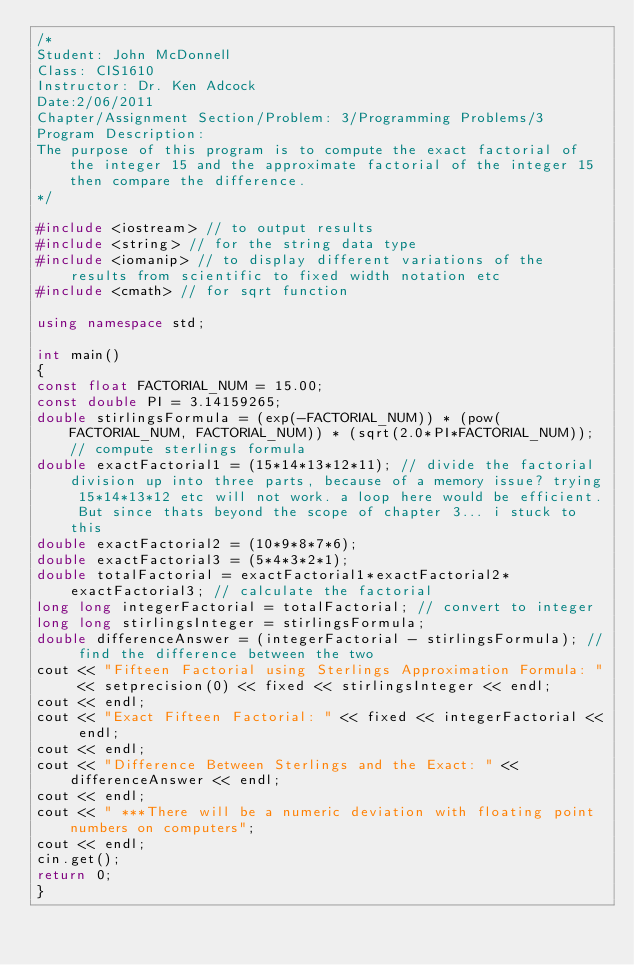<code> <loc_0><loc_0><loc_500><loc_500><_C++_>/* 
Student: John McDonnell
Class: CIS1610
Instructor: Dr. Ken Adcock
Date:2/06/2011
Chapter/Assignment Section/Problem: 3/Programming Problems/3
Program Description:
The purpose of this program is to compute the exact factorial of the integer 15 and the approximate factorial of the integer 15 then compare the difference.
*/

#include <iostream> // to output results
#include <string> // for the string data type
#include <iomanip> // to display different variations of the results from scientific to fixed width notation etc
#include <cmath> // for sqrt function

using namespace std;

int main() 
{
const float FACTORIAL_NUM = 15.00;
const double PI = 3.14159265;
double stirlingsFormula = (exp(-FACTORIAL_NUM)) * (pow(FACTORIAL_NUM, FACTORIAL_NUM)) * (sqrt(2.0*PI*FACTORIAL_NUM)); // compute sterlings formula
double exactFactorial1 = (15*14*13*12*11); // divide the factorial division up into three parts, because of a memory issue? trying 15*14*13*12 etc will not work. a loop here would be efficient. But since thats beyond the scope of chapter 3... i stuck to this
double exactFactorial2 = (10*9*8*7*6);
double exactFactorial3 = (5*4*3*2*1);
double totalFactorial = exactFactorial1*exactFactorial2*exactFactorial3; // calculate the factorial
long long integerFactorial = totalFactorial; // convert to integer 
long long stirlingsInteger = stirlingsFormula;
double differenceAnswer = (integerFactorial - stirlingsFormula); // find the difference between the two
cout << "Fifteen Factorial using Sterlings Approximation Formula: " << setprecision(0) << fixed << stirlingsInteger << endl;
cout << endl;
cout << "Exact Fifteen Factorial: " << fixed << integerFactorial << endl;
cout << endl;
cout << "Difference Between Sterlings and the Exact: " << differenceAnswer << endl;
cout << endl;
cout << " ***There will be a numeric deviation with floating point numbers on computers";
cout << endl;
cin.get();
return 0;
}


</code> 